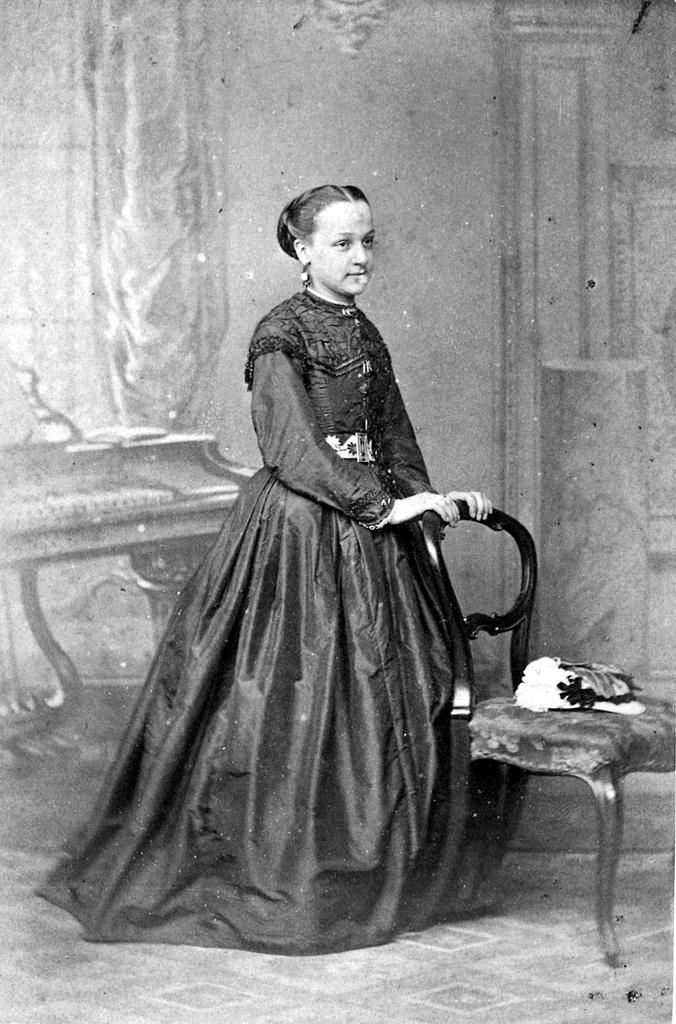Could you give a brief overview of what you see in this image? This picture is clicked inside a room. Woman in black dress standing in the middle of the picture and she is holding chair with her hands. Beside her, we see a chair on which some white color cloth is placed on it. Behind her, we see a wall and table. 